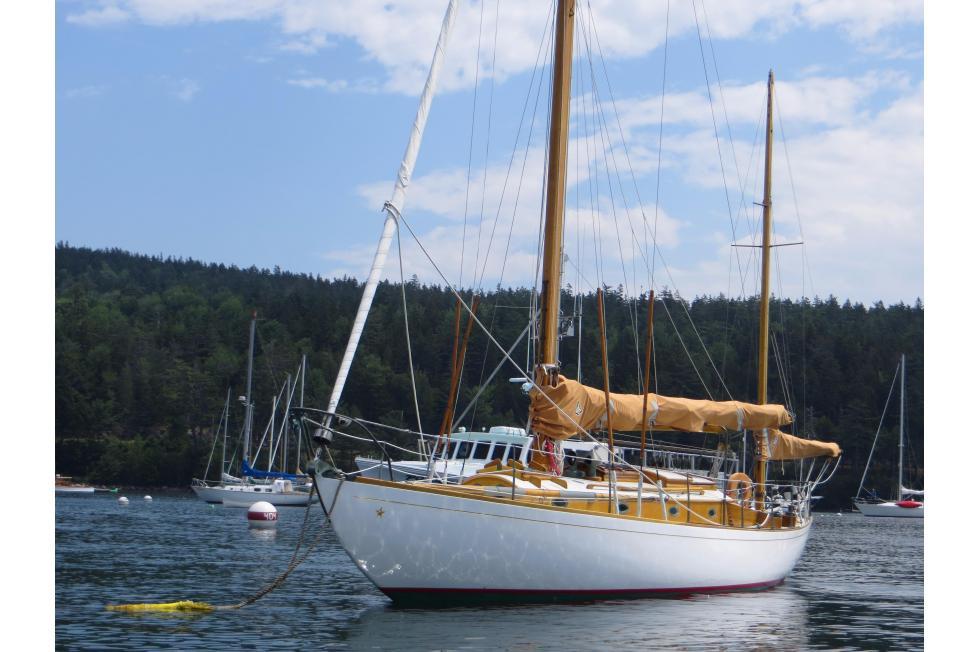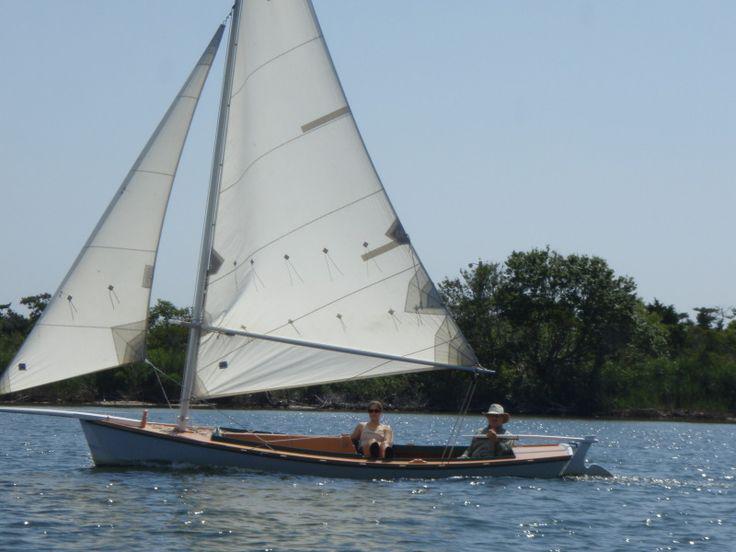The first image is the image on the left, the second image is the image on the right. For the images displayed, is the sentence "The sails are furled in the image on the left." factually correct? Answer yes or no. Yes. 